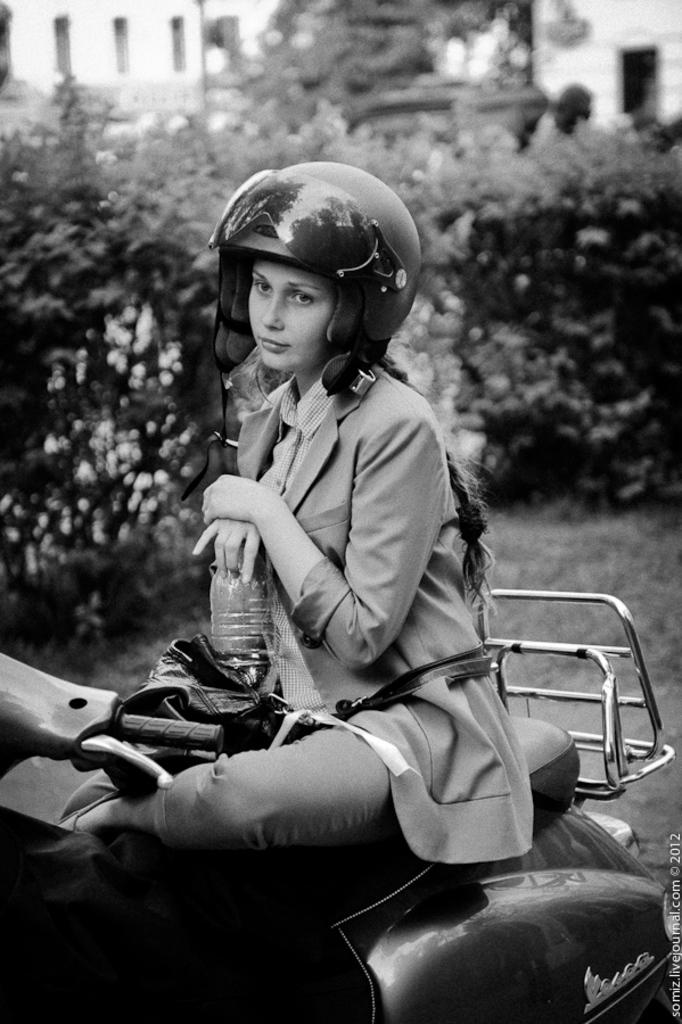Who is the main subject in the image? There is a woman in the image. What is the woman doing in the image? The woman is sitting on a motorcycle. What is the woman holding in her hands? The woman is holding a bottle in her hands. What can be seen in the background of the image? There are trees visible in the image. How many units of cake are visible in the image? There is no cake present in the image. Are there any spiders crawling on the woman's motorcycle in the image? There are no spiders visible in the image. 